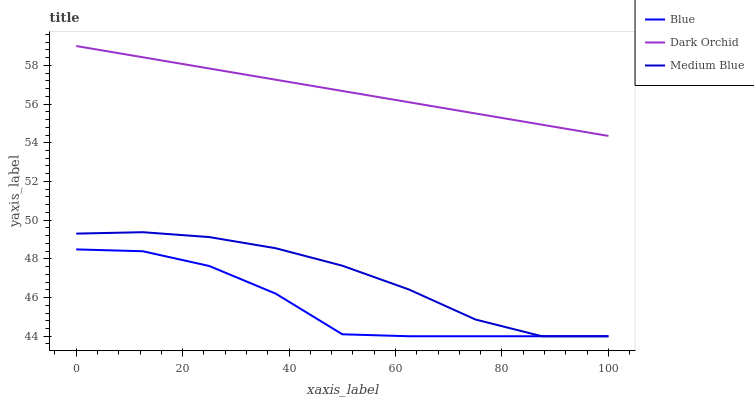Does Blue have the minimum area under the curve?
Answer yes or no. Yes. Does Dark Orchid have the maximum area under the curve?
Answer yes or no. Yes. Does Medium Blue have the minimum area under the curve?
Answer yes or no. No. Does Medium Blue have the maximum area under the curve?
Answer yes or no. No. Is Dark Orchid the smoothest?
Answer yes or no. Yes. Is Blue the roughest?
Answer yes or no. Yes. Is Medium Blue the smoothest?
Answer yes or no. No. Is Medium Blue the roughest?
Answer yes or no. No. Does Blue have the lowest value?
Answer yes or no. Yes. Does Dark Orchid have the lowest value?
Answer yes or no. No. Does Dark Orchid have the highest value?
Answer yes or no. Yes. Does Medium Blue have the highest value?
Answer yes or no. No. Is Blue less than Dark Orchid?
Answer yes or no. Yes. Is Dark Orchid greater than Blue?
Answer yes or no. Yes. Does Medium Blue intersect Blue?
Answer yes or no. Yes. Is Medium Blue less than Blue?
Answer yes or no. No. Is Medium Blue greater than Blue?
Answer yes or no. No. Does Blue intersect Dark Orchid?
Answer yes or no. No. 